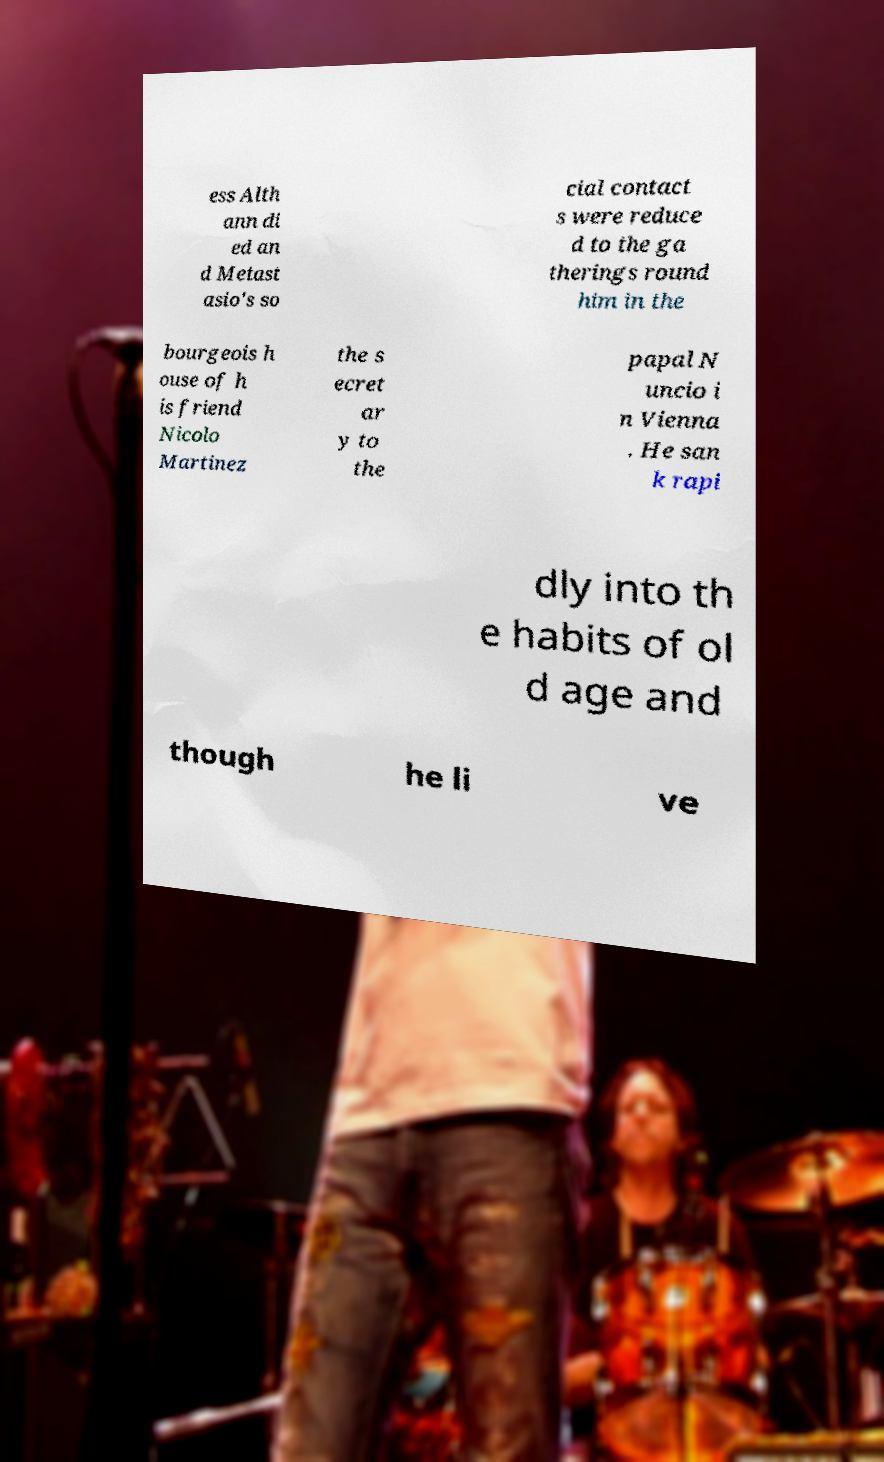There's text embedded in this image that I need extracted. Can you transcribe it verbatim? ess Alth ann di ed an d Metast asio's so cial contact s were reduce d to the ga therings round him in the bourgeois h ouse of h is friend Nicolo Martinez the s ecret ar y to the papal N uncio i n Vienna . He san k rapi dly into th e habits of ol d age and though he li ve 